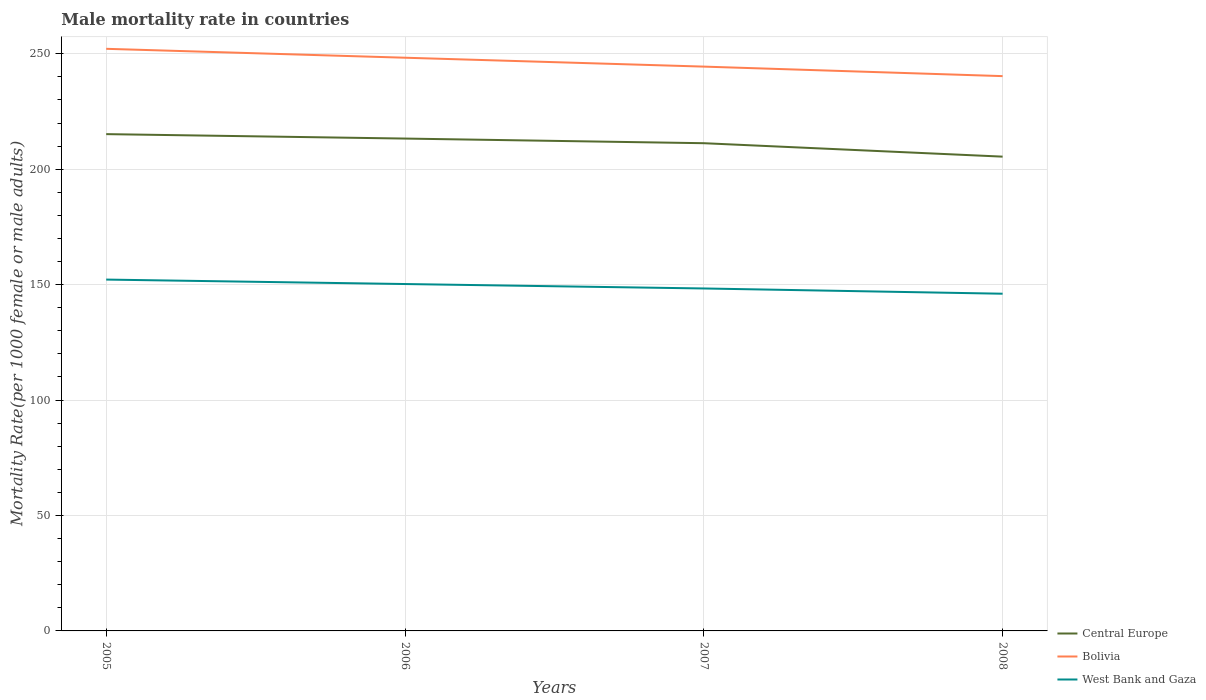How many different coloured lines are there?
Ensure brevity in your answer.  3. Is the number of lines equal to the number of legend labels?
Make the answer very short. Yes. Across all years, what is the maximum male mortality rate in Central Europe?
Provide a short and direct response. 205.43. In which year was the male mortality rate in Bolivia maximum?
Keep it short and to the point. 2008. What is the total male mortality rate in West Bank and Gaza in the graph?
Ensure brevity in your answer.  3.85. What is the difference between the highest and the second highest male mortality rate in Bolivia?
Your answer should be compact. 11.82. Is the male mortality rate in West Bank and Gaza strictly greater than the male mortality rate in Bolivia over the years?
Offer a terse response. Yes. How many lines are there?
Offer a very short reply. 3. What is the difference between two consecutive major ticks on the Y-axis?
Provide a succinct answer. 50. Does the graph contain any zero values?
Offer a terse response. No. Where does the legend appear in the graph?
Your response must be concise. Bottom right. How many legend labels are there?
Make the answer very short. 3. How are the legend labels stacked?
Offer a terse response. Vertical. What is the title of the graph?
Your answer should be compact. Male mortality rate in countries. What is the label or title of the X-axis?
Offer a very short reply. Years. What is the label or title of the Y-axis?
Your answer should be very brief. Mortality Rate(per 1000 female or male adults). What is the Mortality Rate(per 1000 female or male adults) of Central Europe in 2005?
Offer a terse response. 215.18. What is the Mortality Rate(per 1000 female or male adults) of Bolivia in 2005?
Ensure brevity in your answer.  252.13. What is the Mortality Rate(per 1000 female or male adults) of West Bank and Gaza in 2005?
Make the answer very short. 152.18. What is the Mortality Rate(per 1000 female or male adults) in Central Europe in 2006?
Ensure brevity in your answer.  213.26. What is the Mortality Rate(per 1000 female or male adults) in Bolivia in 2006?
Provide a short and direct response. 248.28. What is the Mortality Rate(per 1000 female or male adults) in West Bank and Gaza in 2006?
Give a very brief answer. 150.25. What is the Mortality Rate(per 1000 female or male adults) of Central Europe in 2007?
Provide a succinct answer. 211.25. What is the Mortality Rate(per 1000 female or male adults) in Bolivia in 2007?
Provide a succinct answer. 244.43. What is the Mortality Rate(per 1000 female or male adults) in West Bank and Gaza in 2007?
Make the answer very short. 148.33. What is the Mortality Rate(per 1000 female or male adults) in Central Europe in 2008?
Ensure brevity in your answer.  205.43. What is the Mortality Rate(per 1000 female or male adults) of Bolivia in 2008?
Your response must be concise. 240.31. What is the Mortality Rate(per 1000 female or male adults) of West Bank and Gaza in 2008?
Provide a short and direct response. 146.06. Across all years, what is the maximum Mortality Rate(per 1000 female or male adults) in Central Europe?
Your answer should be very brief. 215.18. Across all years, what is the maximum Mortality Rate(per 1000 female or male adults) of Bolivia?
Keep it short and to the point. 252.13. Across all years, what is the maximum Mortality Rate(per 1000 female or male adults) of West Bank and Gaza?
Your response must be concise. 152.18. Across all years, what is the minimum Mortality Rate(per 1000 female or male adults) of Central Europe?
Ensure brevity in your answer.  205.43. Across all years, what is the minimum Mortality Rate(per 1000 female or male adults) of Bolivia?
Your response must be concise. 240.31. Across all years, what is the minimum Mortality Rate(per 1000 female or male adults) in West Bank and Gaza?
Provide a succinct answer. 146.06. What is the total Mortality Rate(per 1000 female or male adults) of Central Europe in the graph?
Provide a short and direct response. 845.12. What is the total Mortality Rate(per 1000 female or male adults) of Bolivia in the graph?
Give a very brief answer. 985.14. What is the total Mortality Rate(per 1000 female or male adults) in West Bank and Gaza in the graph?
Your answer should be very brief. 596.82. What is the difference between the Mortality Rate(per 1000 female or male adults) in Central Europe in 2005 and that in 2006?
Provide a succinct answer. 1.92. What is the difference between the Mortality Rate(per 1000 female or male adults) of Bolivia in 2005 and that in 2006?
Give a very brief answer. 3.85. What is the difference between the Mortality Rate(per 1000 female or male adults) in West Bank and Gaza in 2005 and that in 2006?
Your response must be concise. 1.93. What is the difference between the Mortality Rate(per 1000 female or male adults) in Central Europe in 2005 and that in 2007?
Offer a very short reply. 3.93. What is the difference between the Mortality Rate(per 1000 female or male adults) in Bolivia in 2005 and that in 2007?
Your answer should be very brief. 7.7. What is the difference between the Mortality Rate(per 1000 female or male adults) of West Bank and Gaza in 2005 and that in 2007?
Your answer should be very brief. 3.85. What is the difference between the Mortality Rate(per 1000 female or male adults) of Central Europe in 2005 and that in 2008?
Your response must be concise. 9.75. What is the difference between the Mortality Rate(per 1000 female or male adults) in Bolivia in 2005 and that in 2008?
Offer a very short reply. 11.82. What is the difference between the Mortality Rate(per 1000 female or male adults) of West Bank and Gaza in 2005 and that in 2008?
Your response must be concise. 6.12. What is the difference between the Mortality Rate(per 1000 female or male adults) in Central Europe in 2006 and that in 2007?
Offer a terse response. 2. What is the difference between the Mortality Rate(per 1000 female or male adults) of Bolivia in 2006 and that in 2007?
Provide a short and direct response. 3.85. What is the difference between the Mortality Rate(per 1000 female or male adults) of West Bank and Gaza in 2006 and that in 2007?
Provide a succinct answer. 1.93. What is the difference between the Mortality Rate(per 1000 female or male adults) of Central Europe in 2006 and that in 2008?
Give a very brief answer. 7.83. What is the difference between the Mortality Rate(per 1000 female or male adults) of Bolivia in 2006 and that in 2008?
Make the answer very short. 7.97. What is the difference between the Mortality Rate(per 1000 female or male adults) in West Bank and Gaza in 2006 and that in 2008?
Ensure brevity in your answer.  4.2. What is the difference between the Mortality Rate(per 1000 female or male adults) in Central Europe in 2007 and that in 2008?
Keep it short and to the point. 5.82. What is the difference between the Mortality Rate(per 1000 female or male adults) of Bolivia in 2007 and that in 2008?
Provide a short and direct response. 4.12. What is the difference between the Mortality Rate(per 1000 female or male adults) in West Bank and Gaza in 2007 and that in 2008?
Your answer should be very brief. 2.27. What is the difference between the Mortality Rate(per 1000 female or male adults) in Central Europe in 2005 and the Mortality Rate(per 1000 female or male adults) in Bolivia in 2006?
Ensure brevity in your answer.  -33.1. What is the difference between the Mortality Rate(per 1000 female or male adults) of Central Europe in 2005 and the Mortality Rate(per 1000 female or male adults) of West Bank and Gaza in 2006?
Ensure brevity in your answer.  64.93. What is the difference between the Mortality Rate(per 1000 female or male adults) in Bolivia in 2005 and the Mortality Rate(per 1000 female or male adults) in West Bank and Gaza in 2006?
Ensure brevity in your answer.  101.88. What is the difference between the Mortality Rate(per 1000 female or male adults) in Central Europe in 2005 and the Mortality Rate(per 1000 female or male adults) in Bolivia in 2007?
Your answer should be compact. -29.25. What is the difference between the Mortality Rate(per 1000 female or male adults) in Central Europe in 2005 and the Mortality Rate(per 1000 female or male adults) in West Bank and Gaza in 2007?
Provide a succinct answer. 66.85. What is the difference between the Mortality Rate(per 1000 female or male adults) in Bolivia in 2005 and the Mortality Rate(per 1000 female or male adults) in West Bank and Gaza in 2007?
Provide a succinct answer. 103.8. What is the difference between the Mortality Rate(per 1000 female or male adults) in Central Europe in 2005 and the Mortality Rate(per 1000 female or male adults) in Bolivia in 2008?
Offer a very short reply. -25.13. What is the difference between the Mortality Rate(per 1000 female or male adults) of Central Europe in 2005 and the Mortality Rate(per 1000 female or male adults) of West Bank and Gaza in 2008?
Give a very brief answer. 69.12. What is the difference between the Mortality Rate(per 1000 female or male adults) in Bolivia in 2005 and the Mortality Rate(per 1000 female or male adults) in West Bank and Gaza in 2008?
Give a very brief answer. 106.07. What is the difference between the Mortality Rate(per 1000 female or male adults) of Central Europe in 2006 and the Mortality Rate(per 1000 female or male adults) of Bolivia in 2007?
Keep it short and to the point. -31.17. What is the difference between the Mortality Rate(per 1000 female or male adults) of Central Europe in 2006 and the Mortality Rate(per 1000 female or male adults) of West Bank and Gaza in 2007?
Ensure brevity in your answer.  64.93. What is the difference between the Mortality Rate(per 1000 female or male adults) in Bolivia in 2006 and the Mortality Rate(per 1000 female or male adults) in West Bank and Gaza in 2007?
Provide a succinct answer. 99.95. What is the difference between the Mortality Rate(per 1000 female or male adults) of Central Europe in 2006 and the Mortality Rate(per 1000 female or male adults) of Bolivia in 2008?
Provide a succinct answer. -27.05. What is the difference between the Mortality Rate(per 1000 female or male adults) of Central Europe in 2006 and the Mortality Rate(per 1000 female or male adults) of West Bank and Gaza in 2008?
Ensure brevity in your answer.  67.2. What is the difference between the Mortality Rate(per 1000 female or male adults) of Bolivia in 2006 and the Mortality Rate(per 1000 female or male adults) of West Bank and Gaza in 2008?
Ensure brevity in your answer.  102.22. What is the difference between the Mortality Rate(per 1000 female or male adults) in Central Europe in 2007 and the Mortality Rate(per 1000 female or male adults) in Bolivia in 2008?
Your answer should be compact. -29.05. What is the difference between the Mortality Rate(per 1000 female or male adults) in Central Europe in 2007 and the Mortality Rate(per 1000 female or male adults) in West Bank and Gaza in 2008?
Keep it short and to the point. 65.2. What is the difference between the Mortality Rate(per 1000 female or male adults) of Bolivia in 2007 and the Mortality Rate(per 1000 female or male adults) of West Bank and Gaza in 2008?
Give a very brief answer. 98.37. What is the average Mortality Rate(per 1000 female or male adults) of Central Europe per year?
Offer a terse response. 211.28. What is the average Mortality Rate(per 1000 female or male adults) in Bolivia per year?
Give a very brief answer. 246.29. What is the average Mortality Rate(per 1000 female or male adults) of West Bank and Gaza per year?
Offer a terse response. 149.21. In the year 2005, what is the difference between the Mortality Rate(per 1000 female or male adults) in Central Europe and Mortality Rate(per 1000 female or male adults) in Bolivia?
Offer a terse response. -36.95. In the year 2005, what is the difference between the Mortality Rate(per 1000 female or male adults) in Central Europe and Mortality Rate(per 1000 female or male adults) in West Bank and Gaza?
Give a very brief answer. 63. In the year 2005, what is the difference between the Mortality Rate(per 1000 female or male adults) in Bolivia and Mortality Rate(per 1000 female or male adults) in West Bank and Gaza?
Provide a short and direct response. 99.95. In the year 2006, what is the difference between the Mortality Rate(per 1000 female or male adults) of Central Europe and Mortality Rate(per 1000 female or male adults) of Bolivia?
Provide a short and direct response. -35.02. In the year 2006, what is the difference between the Mortality Rate(per 1000 female or male adults) of Central Europe and Mortality Rate(per 1000 female or male adults) of West Bank and Gaza?
Provide a short and direct response. 63. In the year 2006, what is the difference between the Mortality Rate(per 1000 female or male adults) of Bolivia and Mortality Rate(per 1000 female or male adults) of West Bank and Gaza?
Offer a terse response. 98.02. In the year 2007, what is the difference between the Mortality Rate(per 1000 female or male adults) in Central Europe and Mortality Rate(per 1000 female or male adults) in Bolivia?
Your answer should be compact. -33.17. In the year 2007, what is the difference between the Mortality Rate(per 1000 female or male adults) of Central Europe and Mortality Rate(per 1000 female or male adults) of West Bank and Gaza?
Give a very brief answer. 62.93. In the year 2007, what is the difference between the Mortality Rate(per 1000 female or male adults) of Bolivia and Mortality Rate(per 1000 female or male adults) of West Bank and Gaza?
Provide a short and direct response. 96.1. In the year 2008, what is the difference between the Mortality Rate(per 1000 female or male adults) in Central Europe and Mortality Rate(per 1000 female or male adults) in Bolivia?
Give a very brief answer. -34.88. In the year 2008, what is the difference between the Mortality Rate(per 1000 female or male adults) of Central Europe and Mortality Rate(per 1000 female or male adults) of West Bank and Gaza?
Ensure brevity in your answer.  59.37. In the year 2008, what is the difference between the Mortality Rate(per 1000 female or male adults) in Bolivia and Mortality Rate(per 1000 female or male adults) in West Bank and Gaza?
Your answer should be very brief. 94.25. What is the ratio of the Mortality Rate(per 1000 female or male adults) in Bolivia in 2005 to that in 2006?
Your response must be concise. 1.02. What is the ratio of the Mortality Rate(per 1000 female or male adults) of West Bank and Gaza in 2005 to that in 2006?
Your response must be concise. 1.01. What is the ratio of the Mortality Rate(per 1000 female or male adults) of Central Europe in 2005 to that in 2007?
Provide a short and direct response. 1.02. What is the ratio of the Mortality Rate(per 1000 female or male adults) in Bolivia in 2005 to that in 2007?
Give a very brief answer. 1.03. What is the ratio of the Mortality Rate(per 1000 female or male adults) of West Bank and Gaza in 2005 to that in 2007?
Provide a short and direct response. 1.03. What is the ratio of the Mortality Rate(per 1000 female or male adults) of Central Europe in 2005 to that in 2008?
Your answer should be very brief. 1.05. What is the ratio of the Mortality Rate(per 1000 female or male adults) of Bolivia in 2005 to that in 2008?
Keep it short and to the point. 1.05. What is the ratio of the Mortality Rate(per 1000 female or male adults) of West Bank and Gaza in 2005 to that in 2008?
Your answer should be compact. 1.04. What is the ratio of the Mortality Rate(per 1000 female or male adults) of Central Europe in 2006 to that in 2007?
Offer a very short reply. 1.01. What is the ratio of the Mortality Rate(per 1000 female or male adults) in Bolivia in 2006 to that in 2007?
Your answer should be compact. 1.02. What is the ratio of the Mortality Rate(per 1000 female or male adults) in Central Europe in 2006 to that in 2008?
Your answer should be very brief. 1.04. What is the ratio of the Mortality Rate(per 1000 female or male adults) in Bolivia in 2006 to that in 2008?
Your response must be concise. 1.03. What is the ratio of the Mortality Rate(per 1000 female or male adults) in West Bank and Gaza in 2006 to that in 2008?
Make the answer very short. 1.03. What is the ratio of the Mortality Rate(per 1000 female or male adults) of Central Europe in 2007 to that in 2008?
Keep it short and to the point. 1.03. What is the ratio of the Mortality Rate(per 1000 female or male adults) of Bolivia in 2007 to that in 2008?
Make the answer very short. 1.02. What is the ratio of the Mortality Rate(per 1000 female or male adults) in West Bank and Gaza in 2007 to that in 2008?
Provide a succinct answer. 1.02. What is the difference between the highest and the second highest Mortality Rate(per 1000 female or male adults) of Central Europe?
Your response must be concise. 1.92. What is the difference between the highest and the second highest Mortality Rate(per 1000 female or male adults) in Bolivia?
Your answer should be compact. 3.85. What is the difference between the highest and the second highest Mortality Rate(per 1000 female or male adults) in West Bank and Gaza?
Make the answer very short. 1.93. What is the difference between the highest and the lowest Mortality Rate(per 1000 female or male adults) in Central Europe?
Offer a very short reply. 9.75. What is the difference between the highest and the lowest Mortality Rate(per 1000 female or male adults) of Bolivia?
Provide a succinct answer. 11.82. What is the difference between the highest and the lowest Mortality Rate(per 1000 female or male adults) of West Bank and Gaza?
Your answer should be compact. 6.12. 